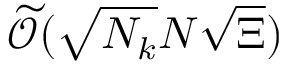<formula> <loc_0><loc_0><loc_500><loc_500>\widetilde { \mathcal { O } } ( \sqrt { N _ { k } } N \sqrt { \Xi } )</formula> 